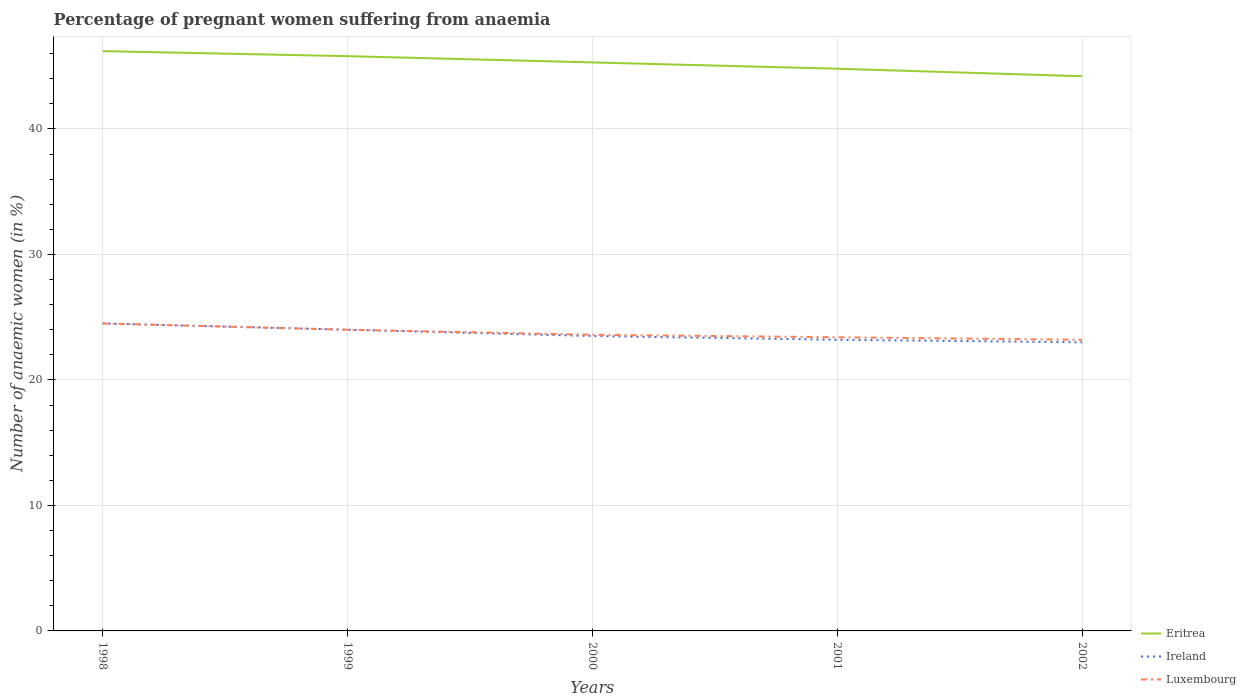How many different coloured lines are there?
Offer a terse response. 3. Is the number of lines equal to the number of legend labels?
Offer a very short reply. Yes. Across all years, what is the maximum number of anaemic women in Eritrea?
Provide a short and direct response. 44.2. In which year was the number of anaemic women in Luxembourg maximum?
Provide a short and direct response. 2002. What is the total number of anaemic women in Luxembourg in the graph?
Your response must be concise. 0.4. What is the difference between the highest and the second highest number of anaemic women in Eritrea?
Ensure brevity in your answer.  2. Is the number of anaemic women in Eritrea strictly greater than the number of anaemic women in Ireland over the years?
Ensure brevity in your answer.  No. How many years are there in the graph?
Your answer should be compact. 5. Are the values on the major ticks of Y-axis written in scientific E-notation?
Your response must be concise. No. Does the graph contain any zero values?
Give a very brief answer. No. How are the legend labels stacked?
Provide a succinct answer. Vertical. What is the title of the graph?
Keep it short and to the point. Percentage of pregnant women suffering from anaemia. What is the label or title of the X-axis?
Your answer should be very brief. Years. What is the label or title of the Y-axis?
Offer a very short reply. Number of anaemic women (in %). What is the Number of anaemic women (in %) of Eritrea in 1998?
Your answer should be compact. 46.2. What is the Number of anaemic women (in %) of Ireland in 1998?
Offer a very short reply. 24.5. What is the Number of anaemic women (in %) of Eritrea in 1999?
Your response must be concise. 45.8. What is the Number of anaemic women (in %) in Ireland in 1999?
Give a very brief answer. 24. What is the Number of anaemic women (in %) of Eritrea in 2000?
Provide a succinct answer. 45.3. What is the Number of anaemic women (in %) of Ireland in 2000?
Give a very brief answer. 23.5. What is the Number of anaemic women (in %) in Luxembourg in 2000?
Provide a short and direct response. 23.6. What is the Number of anaemic women (in %) in Eritrea in 2001?
Offer a very short reply. 44.8. What is the Number of anaemic women (in %) of Ireland in 2001?
Ensure brevity in your answer.  23.2. What is the Number of anaemic women (in %) of Luxembourg in 2001?
Offer a very short reply. 23.4. What is the Number of anaemic women (in %) in Eritrea in 2002?
Keep it short and to the point. 44.2. What is the Number of anaemic women (in %) in Luxembourg in 2002?
Offer a terse response. 23.2. Across all years, what is the maximum Number of anaemic women (in %) in Eritrea?
Your answer should be very brief. 46.2. Across all years, what is the maximum Number of anaemic women (in %) in Ireland?
Your answer should be compact. 24.5. Across all years, what is the minimum Number of anaemic women (in %) in Eritrea?
Provide a succinct answer. 44.2. Across all years, what is the minimum Number of anaemic women (in %) of Ireland?
Give a very brief answer. 23. Across all years, what is the minimum Number of anaemic women (in %) of Luxembourg?
Offer a very short reply. 23.2. What is the total Number of anaemic women (in %) in Eritrea in the graph?
Offer a terse response. 226.3. What is the total Number of anaemic women (in %) in Ireland in the graph?
Your response must be concise. 118.2. What is the total Number of anaemic women (in %) in Luxembourg in the graph?
Your response must be concise. 118.7. What is the difference between the Number of anaemic women (in %) in Luxembourg in 1998 and that in 1999?
Keep it short and to the point. 0.5. What is the difference between the Number of anaemic women (in %) of Ireland in 1998 and that in 2000?
Provide a succinct answer. 1. What is the difference between the Number of anaemic women (in %) in Ireland in 1998 and that in 2002?
Your answer should be compact. 1.5. What is the difference between the Number of anaemic women (in %) of Eritrea in 1999 and that in 2000?
Make the answer very short. 0.5. What is the difference between the Number of anaemic women (in %) of Ireland in 1999 and that in 2001?
Keep it short and to the point. 0.8. What is the difference between the Number of anaemic women (in %) in Luxembourg in 1999 and that in 2002?
Offer a terse response. 0.8. What is the difference between the Number of anaemic women (in %) in Ireland in 2000 and that in 2001?
Your answer should be compact. 0.3. What is the difference between the Number of anaemic women (in %) of Luxembourg in 2000 and that in 2001?
Offer a very short reply. 0.2. What is the difference between the Number of anaemic women (in %) in Ireland in 2000 and that in 2002?
Your answer should be compact. 0.5. What is the difference between the Number of anaemic women (in %) in Luxembourg in 2000 and that in 2002?
Your response must be concise. 0.4. What is the difference between the Number of anaemic women (in %) of Luxembourg in 2001 and that in 2002?
Your response must be concise. 0.2. What is the difference between the Number of anaemic women (in %) in Eritrea in 1998 and the Number of anaemic women (in %) in Luxembourg in 1999?
Ensure brevity in your answer.  22.2. What is the difference between the Number of anaemic women (in %) of Ireland in 1998 and the Number of anaemic women (in %) of Luxembourg in 1999?
Your answer should be compact. 0.5. What is the difference between the Number of anaemic women (in %) of Eritrea in 1998 and the Number of anaemic women (in %) of Ireland in 2000?
Provide a succinct answer. 22.7. What is the difference between the Number of anaemic women (in %) of Eritrea in 1998 and the Number of anaemic women (in %) of Luxembourg in 2000?
Your answer should be very brief. 22.6. What is the difference between the Number of anaemic women (in %) in Ireland in 1998 and the Number of anaemic women (in %) in Luxembourg in 2000?
Ensure brevity in your answer.  0.9. What is the difference between the Number of anaemic women (in %) in Eritrea in 1998 and the Number of anaemic women (in %) in Luxembourg in 2001?
Keep it short and to the point. 22.8. What is the difference between the Number of anaemic women (in %) of Ireland in 1998 and the Number of anaemic women (in %) of Luxembourg in 2001?
Your answer should be compact. 1.1. What is the difference between the Number of anaemic women (in %) in Eritrea in 1998 and the Number of anaemic women (in %) in Ireland in 2002?
Ensure brevity in your answer.  23.2. What is the difference between the Number of anaemic women (in %) of Ireland in 1998 and the Number of anaemic women (in %) of Luxembourg in 2002?
Give a very brief answer. 1.3. What is the difference between the Number of anaemic women (in %) in Eritrea in 1999 and the Number of anaemic women (in %) in Ireland in 2000?
Provide a succinct answer. 22.3. What is the difference between the Number of anaemic women (in %) in Eritrea in 1999 and the Number of anaemic women (in %) in Luxembourg in 2000?
Make the answer very short. 22.2. What is the difference between the Number of anaemic women (in %) of Ireland in 1999 and the Number of anaemic women (in %) of Luxembourg in 2000?
Make the answer very short. 0.4. What is the difference between the Number of anaemic women (in %) in Eritrea in 1999 and the Number of anaemic women (in %) in Ireland in 2001?
Offer a terse response. 22.6. What is the difference between the Number of anaemic women (in %) in Eritrea in 1999 and the Number of anaemic women (in %) in Luxembourg in 2001?
Offer a terse response. 22.4. What is the difference between the Number of anaemic women (in %) of Eritrea in 1999 and the Number of anaemic women (in %) of Ireland in 2002?
Your answer should be compact. 22.8. What is the difference between the Number of anaemic women (in %) in Eritrea in 1999 and the Number of anaemic women (in %) in Luxembourg in 2002?
Offer a terse response. 22.6. What is the difference between the Number of anaemic women (in %) in Ireland in 1999 and the Number of anaemic women (in %) in Luxembourg in 2002?
Give a very brief answer. 0.8. What is the difference between the Number of anaemic women (in %) in Eritrea in 2000 and the Number of anaemic women (in %) in Ireland in 2001?
Make the answer very short. 22.1. What is the difference between the Number of anaemic women (in %) of Eritrea in 2000 and the Number of anaemic women (in %) of Luxembourg in 2001?
Keep it short and to the point. 21.9. What is the difference between the Number of anaemic women (in %) of Eritrea in 2000 and the Number of anaemic women (in %) of Ireland in 2002?
Make the answer very short. 22.3. What is the difference between the Number of anaemic women (in %) in Eritrea in 2000 and the Number of anaemic women (in %) in Luxembourg in 2002?
Offer a very short reply. 22.1. What is the difference between the Number of anaemic women (in %) in Eritrea in 2001 and the Number of anaemic women (in %) in Ireland in 2002?
Keep it short and to the point. 21.8. What is the difference between the Number of anaemic women (in %) of Eritrea in 2001 and the Number of anaemic women (in %) of Luxembourg in 2002?
Provide a succinct answer. 21.6. What is the average Number of anaemic women (in %) of Eritrea per year?
Make the answer very short. 45.26. What is the average Number of anaemic women (in %) of Ireland per year?
Keep it short and to the point. 23.64. What is the average Number of anaemic women (in %) of Luxembourg per year?
Make the answer very short. 23.74. In the year 1998, what is the difference between the Number of anaemic women (in %) in Eritrea and Number of anaemic women (in %) in Ireland?
Your answer should be compact. 21.7. In the year 1998, what is the difference between the Number of anaemic women (in %) in Eritrea and Number of anaemic women (in %) in Luxembourg?
Give a very brief answer. 21.7. In the year 1999, what is the difference between the Number of anaemic women (in %) of Eritrea and Number of anaemic women (in %) of Ireland?
Provide a short and direct response. 21.8. In the year 1999, what is the difference between the Number of anaemic women (in %) in Eritrea and Number of anaemic women (in %) in Luxembourg?
Your answer should be very brief. 21.8. In the year 1999, what is the difference between the Number of anaemic women (in %) in Ireland and Number of anaemic women (in %) in Luxembourg?
Provide a succinct answer. 0. In the year 2000, what is the difference between the Number of anaemic women (in %) in Eritrea and Number of anaemic women (in %) in Ireland?
Offer a terse response. 21.8. In the year 2000, what is the difference between the Number of anaemic women (in %) of Eritrea and Number of anaemic women (in %) of Luxembourg?
Ensure brevity in your answer.  21.7. In the year 2001, what is the difference between the Number of anaemic women (in %) of Eritrea and Number of anaemic women (in %) of Ireland?
Give a very brief answer. 21.6. In the year 2001, what is the difference between the Number of anaemic women (in %) in Eritrea and Number of anaemic women (in %) in Luxembourg?
Keep it short and to the point. 21.4. In the year 2001, what is the difference between the Number of anaemic women (in %) in Ireland and Number of anaemic women (in %) in Luxembourg?
Keep it short and to the point. -0.2. In the year 2002, what is the difference between the Number of anaemic women (in %) in Eritrea and Number of anaemic women (in %) in Ireland?
Provide a succinct answer. 21.2. In the year 2002, what is the difference between the Number of anaemic women (in %) of Eritrea and Number of anaemic women (in %) of Luxembourg?
Give a very brief answer. 21. In the year 2002, what is the difference between the Number of anaemic women (in %) in Ireland and Number of anaemic women (in %) in Luxembourg?
Make the answer very short. -0.2. What is the ratio of the Number of anaemic women (in %) of Eritrea in 1998 to that in 1999?
Ensure brevity in your answer.  1.01. What is the ratio of the Number of anaemic women (in %) in Ireland in 1998 to that in 1999?
Your answer should be very brief. 1.02. What is the ratio of the Number of anaemic women (in %) of Luxembourg in 1998 to that in 1999?
Your answer should be very brief. 1.02. What is the ratio of the Number of anaemic women (in %) of Eritrea in 1998 to that in 2000?
Provide a short and direct response. 1.02. What is the ratio of the Number of anaemic women (in %) in Ireland in 1998 to that in 2000?
Your answer should be very brief. 1.04. What is the ratio of the Number of anaemic women (in %) of Luxembourg in 1998 to that in 2000?
Your answer should be very brief. 1.04. What is the ratio of the Number of anaemic women (in %) in Eritrea in 1998 to that in 2001?
Your answer should be very brief. 1.03. What is the ratio of the Number of anaemic women (in %) in Ireland in 1998 to that in 2001?
Offer a very short reply. 1.06. What is the ratio of the Number of anaemic women (in %) in Luxembourg in 1998 to that in 2001?
Provide a succinct answer. 1.05. What is the ratio of the Number of anaemic women (in %) of Eritrea in 1998 to that in 2002?
Provide a short and direct response. 1.05. What is the ratio of the Number of anaemic women (in %) in Ireland in 1998 to that in 2002?
Offer a terse response. 1.07. What is the ratio of the Number of anaemic women (in %) of Luxembourg in 1998 to that in 2002?
Your answer should be compact. 1.06. What is the ratio of the Number of anaemic women (in %) of Ireland in 1999 to that in 2000?
Give a very brief answer. 1.02. What is the ratio of the Number of anaemic women (in %) of Luxembourg in 1999 to that in 2000?
Give a very brief answer. 1.02. What is the ratio of the Number of anaemic women (in %) in Eritrea in 1999 to that in 2001?
Offer a terse response. 1.02. What is the ratio of the Number of anaemic women (in %) in Ireland in 1999 to that in 2001?
Your response must be concise. 1.03. What is the ratio of the Number of anaemic women (in %) in Luxembourg in 1999 to that in 2001?
Offer a terse response. 1.03. What is the ratio of the Number of anaemic women (in %) of Eritrea in 1999 to that in 2002?
Provide a short and direct response. 1.04. What is the ratio of the Number of anaemic women (in %) of Ireland in 1999 to that in 2002?
Offer a terse response. 1.04. What is the ratio of the Number of anaemic women (in %) of Luxembourg in 1999 to that in 2002?
Ensure brevity in your answer.  1.03. What is the ratio of the Number of anaemic women (in %) in Eritrea in 2000 to that in 2001?
Offer a very short reply. 1.01. What is the ratio of the Number of anaemic women (in %) of Ireland in 2000 to that in 2001?
Your response must be concise. 1.01. What is the ratio of the Number of anaemic women (in %) of Luxembourg in 2000 to that in 2001?
Your response must be concise. 1.01. What is the ratio of the Number of anaemic women (in %) in Eritrea in 2000 to that in 2002?
Your answer should be very brief. 1.02. What is the ratio of the Number of anaemic women (in %) in Ireland in 2000 to that in 2002?
Your response must be concise. 1.02. What is the ratio of the Number of anaemic women (in %) in Luxembourg in 2000 to that in 2002?
Keep it short and to the point. 1.02. What is the ratio of the Number of anaemic women (in %) of Eritrea in 2001 to that in 2002?
Give a very brief answer. 1.01. What is the ratio of the Number of anaemic women (in %) in Ireland in 2001 to that in 2002?
Your answer should be compact. 1.01. What is the ratio of the Number of anaemic women (in %) in Luxembourg in 2001 to that in 2002?
Keep it short and to the point. 1.01. What is the difference between the highest and the second highest Number of anaemic women (in %) of Luxembourg?
Provide a succinct answer. 0.5. What is the difference between the highest and the lowest Number of anaemic women (in %) of Eritrea?
Give a very brief answer. 2. What is the difference between the highest and the lowest Number of anaemic women (in %) in Ireland?
Offer a very short reply. 1.5. 